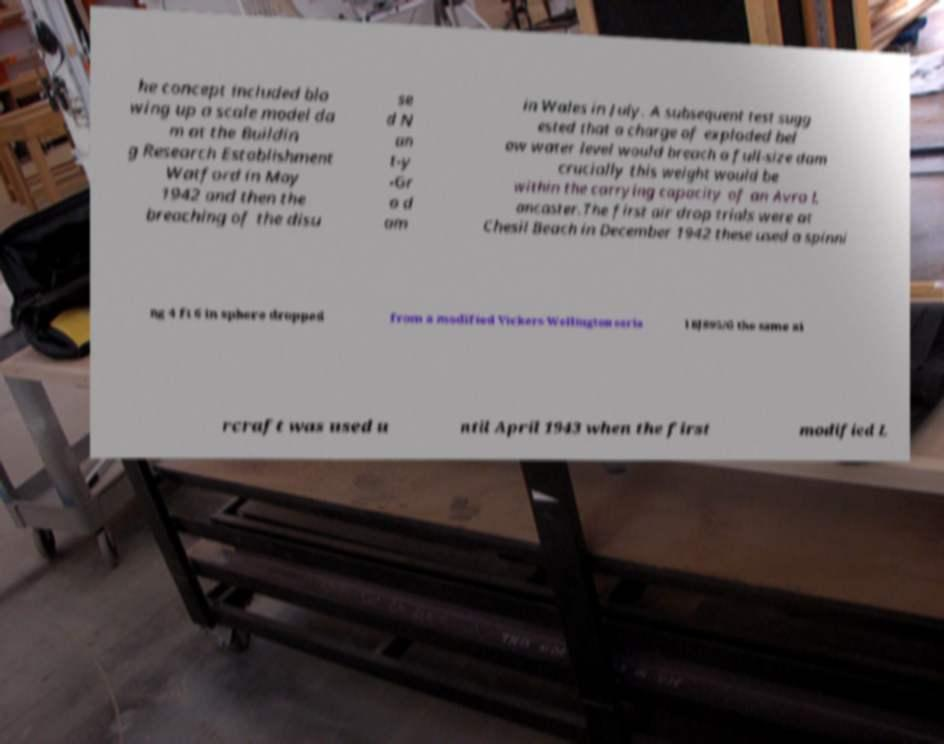Could you extract and type out the text from this image? he concept included blo wing up a scale model da m at the Buildin g Research Establishment Watford in May 1942 and then the breaching of the disu se d N an t-y -Gr o d am in Wales in July. A subsequent test sugg ested that a charge of exploded bel ow water level would breach a full-size dam crucially this weight would be within the carrying capacity of an Avro L ancaster.The first air drop trials were at Chesil Beach in December 1942 these used a spinni ng 4 ft 6 in sphere dropped from a modified Vickers Wellington seria l BJ895/G the same ai rcraft was used u ntil April 1943 when the first modified L 